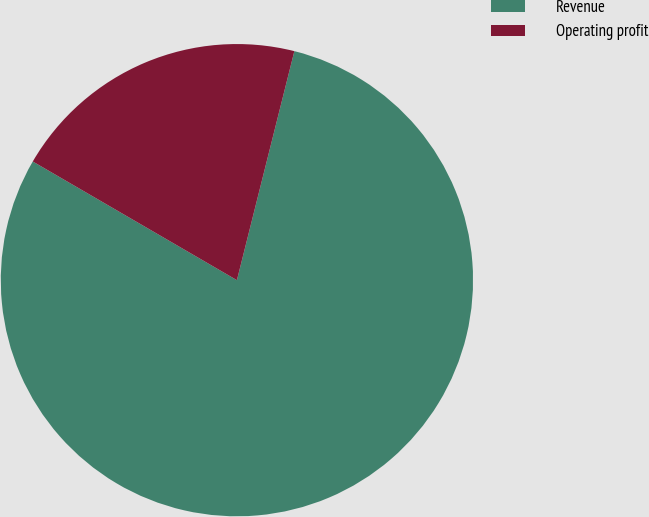Convert chart to OTSL. <chart><loc_0><loc_0><loc_500><loc_500><pie_chart><fcel>Revenue<fcel>Operating profit<nl><fcel>79.47%<fcel>20.53%<nl></chart> 